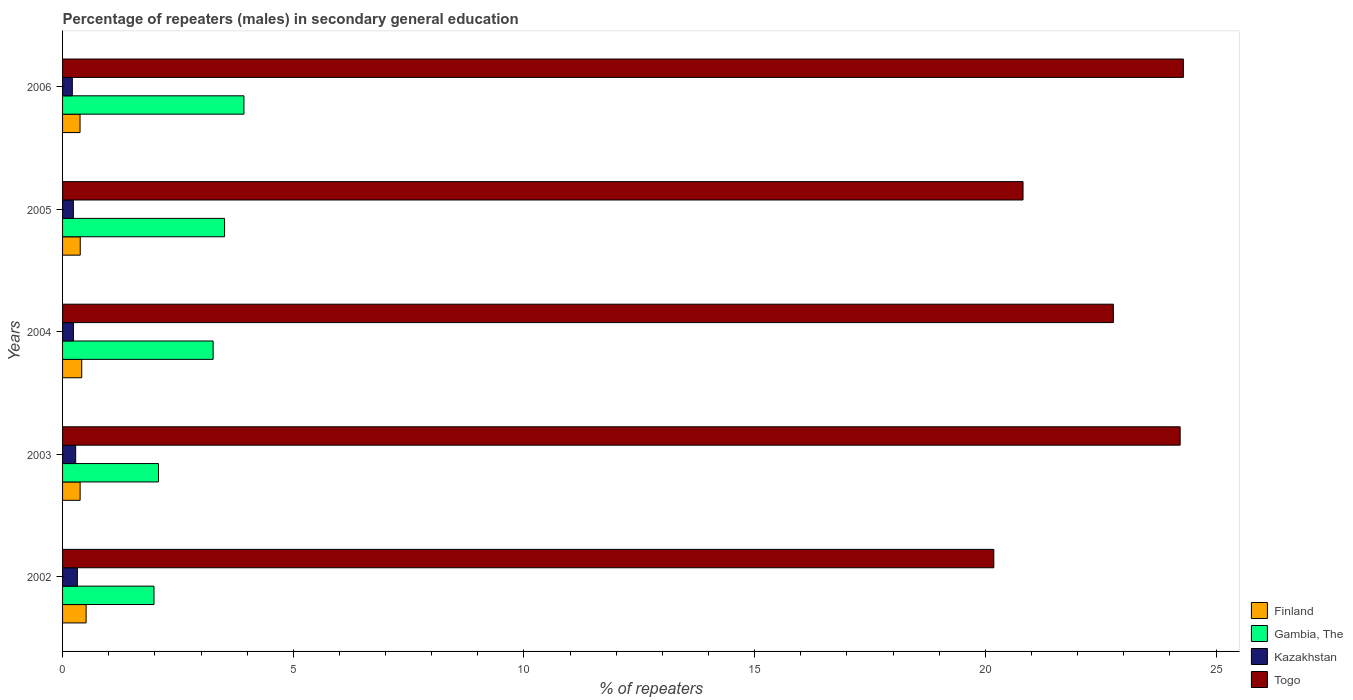How many different coloured bars are there?
Your response must be concise. 4. How many groups of bars are there?
Provide a short and direct response. 5. Are the number of bars on each tick of the Y-axis equal?
Your answer should be compact. Yes. How many bars are there on the 3rd tick from the bottom?
Provide a succinct answer. 4. What is the percentage of male repeaters in Togo in 2006?
Offer a terse response. 24.29. Across all years, what is the maximum percentage of male repeaters in Kazakhstan?
Provide a short and direct response. 0.32. Across all years, what is the minimum percentage of male repeaters in Finland?
Offer a very short reply. 0.38. In which year was the percentage of male repeaters in Togo maximum?
Your answer should be very brief. 2006. In which year was the percentage of male repeaters in Kazakhstan minimum?
Offer a terse response. 2006. What is the total percentage of male repeaters in Finland in the graph?
Make the answer very short. 2.07. What is the difference between the percentage of male repeaters in Finland in 2004 and that in 2006?
Provide a short and direct response. 0.04. What is the difference between the percentage of male repeaters in Gambia, The in 2005 and the percentage of male repeaters in Togo in 2003?
Your answer should be very brief. -20.71. What is the average percentage of male repeaters in Gambia, The per year?
Ensure brevity in your answer.  2.95. In the year 2004, what is the difference between the percentage of male repeaters in Kazakhstan and percentage of male repeaters in Finland?
Ensure brevity in your answer.  -0.18. In how many years, is the percentage of male repeaters in Togo greater than 23 %?
Keep it short and to the point. 2. What is the ratio of the percentage of male repeaters in Gambia, The in 2003 to that in 2005?
Ensure brevity in your answer.  0.59. Is the difference between the percentage of male repeaters in Kazakhstan in 2003 and 2005 greater than the difference between the percentage of male repeaters in Finland in 2003 and 2005?
Your response must be concise. Yes. What is the difference between the highest and the second highest percentage of male repeaters in Gambia, The?
Make the answer very short. 0.42. What is the difference between the highest and the lowest percentage of male repeaters in Gambia, The?
Provide a short and direct response. 1.95. In how many years, is the percentage of male repeaters in Finland greater than the average percentage of male repeaters in Finland taken over all years?
Your answer should be very brief. 2. Is the sum of the percentage of male repeaters in Kazakhstan in 2004 and 2006 greater than the maximum percentage of male repeaters in Togo across all years?
Make the answer very short. No. What does the 2nd bar from the bottom in 2004 represents?
Your answer should be compact. Gambia, The. Is it the case that in every year, the sum of the percentage of male repeaters in Kazakhstan and percentage of male repeaters in Togo is greater than the percentage of male repeaters in Finland?
Make the answer very short. Yes. How many years are there in the graph?
Make the answer very short. 5. Are the values on the major ticks of X-axis written in scientific E-notation?
Keep it short and to the point. No. Does the graph contain any zero values?
Provide a short and direct response. No. Does the graph contain grids?
Give a very brief answer. No. Where does the legend appear in the graph?
Ensure brevity in your answer.  Bottom right. How many legend labels are there?
Provide a succinct answer. 4. How are the legend labels stacked?
Give a very brief answer. Vertical. What is the title of the graph?
Make the answer very short. Percentage of repeaters (males) in secondary general education. Does "Serbia" appear as one of the legend labels in the graph?
Offer a very short reply. No. What is the label or title of the X-axis?
Ensure brevity in your answer.  % of repeaters. What is the label or title of the Y-axis?
Give a very brief answer. Years. What is the % of repeaters in Finland in 2002?
Your answer should be very brief. 0.51. What is the % of repeaters in Gambia, The in 2002?
Provide a succinct answer. 1.98. What is the % of repeaters in Kazakhstan in 2002?
Keep it short and to the point. 0.32. What is the % of repeaters in Togo in 2002?
Keep it short and to the point. 20.18. What is the % of repeaters of Finland in 2003?
Give a very brief answer. 0.38. What is the % of repeaters in Gambia, The in 2003?
Keep it short and to the point. 2.08. What is the % of repeaters of Kazakhstan in 2003?
Offer a terse response. 0.28. What is the % of repeaters in Togo in 2003?
Your answer should be very brief. 24.22. What is the % of repeaters of Finland in 2004?
Provide a succinct answer. 0.42. What is the % of repeaters in Gambia, The in 2004?
Provide a succinct answer. 3.26. What is the % of repeaters in Kazakhstan in 2004?
Your response must be concise. 0.24. What is the % of repeaters in Togo in 2004?
Your answer should be compact. 22.77. What is the % of repeaters of Finland in 2005?
Provide a succinct answer. 0.38. What is the % of repeaters of Gambia, The in 2005?
Offer a very short reply. 3.51. What is the % of repeaters of Kazakhstan in 2005?
Give a very brief answer. 0.23. What is the % of repeaters of Togo in 2005?
Offer a terse response. 20.82. What is the % of repeaters of Finland in 2006?
Provide a succinct answer. 0.38. What is the % of repeaters in Gambia, The in 2006?
Make the answer very short. 3.93. What is the % of repeaters in Kazakhstan in 2006?
Ensure brevity in your answer.  0.21. What is the % of repeaters of Togo in 2006?
Your response must be concise. 24.29. Across all years, what is the maximum % of repeaters in Finland?
Give a very brief answer. 0.51. Across all years, what is the maximum % of repeaters in Gambia, The?
Make the answer very short. 3.93. Across all years, what is the maximum % of repeaters in Kazakhstan?
Provide a short and direct response. 0.32. Across all years, what is the maximum % of repeaters in Togo?
Keep it short and to the point. 24.29. Across all years, what is the minimum % of repeaters in Finland?
Make the answer very short. 0.38. Across all years, what is the minimum % of repeaters in Gambia, The?
Make the answer very short. 1.98. Across all years, what is the minimum % of repeaters in Kazakhstan?
Your response must be concise. 0.21. Across all years, what is the minimum % of repeaters in Togo?
Offer a very short reply. 20.18. What is the total % of repeaters in Finland in the graph?
Ensure brevity in your answer.  2.07. What is the total % of repeaters of Gambia, The in the graph?
Provide a succinct answer. 14.77. What is the total % of repeaters in Kazakhstan in the graph?
Offer a terse response. 1.29. What is the total % of repeaters in Togo in the graph?
Ensure brevity in your answer.  112.28. What is the difference between the % of repeaters in Finland in 2002 and that in 2003?
Your response must be concise. 0.13. What is the difference between the % of repeaters of Gambia, The in 2002 and that in 2003?
Keep it short and to the point. -0.1. What is the difference between the % of repeaters of Kazakhstan in 2002 and that in 2003?
Provide a succinct answer. 0.04. What is the difference between the % of repeaters of Togo in 2002 and that in 2003?
Offer a terse response. -4.04. What is the difference between the % of repeaters of Finland in 2002 and that in 2004?
Offer a terse response. 0.09. What is the difference between the % of repeaters in Gambia, The in 2002 and that in 2004?
Make the answer very short. -1.28. What is the difference between the % of repeaters of Kazakhstan in 2002 and that in 2004?
Offer a terse response. 0.09. What is the difference between the % of repeaters of Togo in 2002 and that in 2004?
Make the answer very short. -2.59. What is the difference between the % of repeaters of Finland in 2002 and that in 2005?
Give a very brief answer. 0.13. What is the difference between the % of repeaters of Gambia, The in 2002 and that in 2005?
Offer a terse response. -1.53. What is the difference between the % of repeaters of Kazakhstan in 2002 and that in 2005?
Offer a terse response. 0.09. What is the difference between the % of repeaters of Togo in 2002 and that in 2005?
Keep it short and to the point. -0.63. What is the difference between the % of repeaters in Finland in 2002 and that in 2006?
Offer a terse response. 0.13. What is the difference between the % of repeaters of Gambia, The in 2002 and that in 2006?
Offer a terse response. -1.95. What is the difference between the % of repeaters in Kazakhstan in 2002 and that in 2006?
Your answer should be very brief. 0.11. What is the difference between the % of repeaters of Togo in 2002 and that in 2006?
Make the answer very short. -4.11. What is the difference between the % of repeaters of Finland in 2003 and that in 2004?
Make the answer very short. -0.04. What is the difference between the % of repeaters in Gambia, The in 2003 and that in 2004?
Provide a succinct answer. -1.18. What is the difference between the % of repeaters of Kazakhstan in 2003 and that in 2004?
Your response must be concise. 0.05. What is the difference between the % of repeaters of Togo in 2003 and that in 2004?
Offer a very short reply. 1.45. What is the difference between the % of repeaters in Finland in 2003 and that in 2005?
Offer a terse response. -0. What is the difference between the % of repeaters of Gambia, The in 2003 and that in 2005?
Your response must be concise. -1.43. What is the difference between the % of repeaters in Kazakhstan in 2003 and that in 2005?
Your answer should be compact. 0.05. What is the difference between the % of repeaters in Togo in 2003 and that in 2005?
Make the answer very short. 3.41. What is the difference between the % of repeaters in Finland in 2003 and that in 2006?
Ensure brevity in your answer.  0. What is the difference between the % of repeaters of Gambia, The in 2003 and that in 2006?
Provide a succinct answer. -1.85. What is the difference between the % of repeaters in Kazakhstan in 2003 and that in 2006?
Provide a succinct answer. 0.07. What is the difference between the % of repeaters in Togo in 2003 and that in 2006?
Offer a terse response. -0.07. What is the difference between the % of repeaters in Finland in 2004 and that in 2005?
Give a very brief answer. 0.03. What is the difference between the % of repeaters in Gambia, The in 2004 and that in 2005?
Provide a short and direct response. -0.25. What is the difference between the % of repeaters of Togo in 2004 and that in 2005?
Ensure brevity in your answer.  1.96. What is the difference between the % of repeaters of Finland in 2004 and that in 2006?
Your answer should be very brief. 0.04. What is the difference between the % of repeaters in Gambia, The in 2004 and that in 2006?
Give a very brief answer. -0.67. What is the difference between the % of repeaters of Kazakhstan in 2004 and that in 2006?
Keep it short and to the point. 0.02. What is the difference between the % of repeaters in Togo in 2004 and that in 2006?
Provide a succinct answer. -1.52. What is the difference between the % of repeaters in Finland in 2005 and that in 2006?
Provide a succinct answer. 0. What is the difference between the % of repeaters in Gambia, The in 2005 and that in 2006?
Offer a terse response. -0.42. What is the difference between the % of repeaters of Kazakhstan in 2005 and that in 2006?
Make the answer very short. 0.02. What is the difference between the % of repeaters in Togo in 2005 and that in 2006?
Make the answer very short. -3.47. What is the difference between the % of repeaters of Finland in 2002 and the % of repeaters of Gambia, The in 2003?
Provide a succinct answer. -1.57. What is the difference between the % of repeaters in Finland in 2002 and the % of repeaters in Kazakhstan in 2003?
Offer a very short reply. 0.23. What is the difference between the % of repeaters of Finland in 2002 and the % of repeaters of Togo in 2003?
Keep it short and to the point. -23.71. What is the difference between the % of repeaters in Gambia, The in 2002 and the % of repeaters in Kazakhstan in 2003?
Offer a terse response. 1.7. What is the difference between the % of repeaters of Gambia, The in 2002 and the % of repeaters of Togo in 2003?
Provide a short and direct response. -22.24. What is the difference between the % of repeaters of Kazakhstan in 2002 and the % of repeaters of Togo in 2003?
Provide a succinct answer. -23.9. What is the difference between the % of repeaters in Finland in 2002 and the % of repeaters in Gambia, The in 2004?
Make the answer very short. -2.75. What is the difference between the % of repeaters in Finland in 2002 and the % of repeaters in Kazakhstan in 2004?
Your answer should be compact. 0.27. What is the difference between the % of repeaters in Finland in 2002 and the % of repeaters in Togo in 2004?
Offer a very short reply. -22.26. What is the difference between the % of repeaters of Gambia, The in 2002 and the % of repeaters of Kazakhstan in 2004?
Provide a short and direct response. 1.75. What is the difference between the % of repeaters in Gambia, The in 2002 and the % of repeaters in Togo in 2004?
Provide a succinct answer. -20.79. What is the difference between the % of repeaters of Kazakhstan in 2002 and the % of repeaters of Togo in 2004?
Your answer should be very brief. -22.45. What is the difference between the % of repeaters in Finland in 2002 and the % of repeaters in Gambia, The in 2005?
Make the answer very short. -3. What is the difference between the % of repeaters of Finland in 2002 and the % of repeaters of Kazakhstan in 2005?
Your response must be concise. 0.28. What is the difference between the % of repeaters of Finland in 2002 and the % of repeaters of Togo in 2005?
Make the answer very short. -20.31. What is the difference between the % of repeaters in Gambia, The in 2002 and the % of repeaters in Kazakhstan in 2005?
Make the answer very short. 1.75. What is the difference between the % of repeaters of Gambia, The in 2002 and the % of repeaters of Togo in 2005?
Your answer should be compact. -18.83. What is the difference between the % of repeaters of Kazakhstan in 2002 and the % of repeaters of Togo in 2005?
Offer a terse response. -20.49. What is the difference between the % of repeaters in Finland in 2002 and the % of repeaters in Gambia, The in 2006?
Give a very brief answer. -3.42. What is the difference between the % of repeaters in Finland in 2002 and the % of repeaters in Kazakhstan in 2006?
Ensure brevity in your answer.  0.3. What is the difference between the % of repeaters of Finland in 2002 and the % of repeaters of Togo in 2006?
Your response must be concise. -23.78. What is the difference between the % of repeaters of Gambia, The in 2002 and the % of repeaters of Kazakhstan in 2006?
Offer a terse response. 1.77. What is the difference between the % of repeaters in Gambia, The in 2002 and the % of repeaters in Togo in 2006?
Your response must be concise. -22.31. What is the difference between the % of repeaters in Kazakhstan in 2002 and the % of repeaters in Togo in 2006?
Give a very brief answer. -23.97. What is the difference between the % of repeaters of Finland in 2003 and the % of repeaters of Gambia, The in 2004?
Offer a terse response. -2.88. What is the difference between the % of repeaters of Finland in 2003 and the % of repeaters of Kazakhstan in 2004?
Offer a terse response. 0.15. What is the difference between the % of repeaters of Finland in 2003 and the % of repeaters of Togo in 2004?
Offer a very short reply. -22.39. What is the difference between the % of repeaters of Gambia, The in 2003 and the % of repeaters of Kazakhstan in 2004?
Your answer should be very brief. 1.84. What is the difference between the % of repeaters in Gambia, The in 2003 and the % of repeaters in Togo in 2004?
Keep it short and to the point. -20.69. What is the difference between the % of repeaters in Kazakhstan in 2003 and the % of repeaters in Togo in 2004?
Your answer should be very brief. -22.49. What is the difference between the % of repeaters in Finland in 2003 and the % of repeaters in Gambia, The in 2005?
Your response must be concise. -3.13. What is the difference between the % of repeaters of Finland in 2003 and the % of repeaters of Kazakhstan in 2005?
Your answer should be compact. 0.15. What is the difference between the % of repeaters in Finland in 2003 and the % of repeaters in Togo in 2005?
Offer a terse response. -20.43. What is the difference between the % of repeaters of Gambia, The in 2003 and the % of repeaters of Kazakhstan in 2005?
Your response must be concise. 1.84. What is the difference between the % of repeaters of Gambia, The in 2003 and the % of repeaters of Togo in 2005?
Offer a very short reply. -18.74. What is the difference between the % of repeaters of Kazakhstan in 2003 and the % of repeaters of Togo in 2005?
Offer a terse response. -20.53. What is the difference between the % of repeaters in Finland in 2003 and the % of repeaters in Gambia, The in 2006?
Provide a succinct answer. -3.55. What is the difference between the % of repeaters in Finland in 2003 and the % of repeaters in Kazakhstan in 2006?
Provide a succinct answer. 0.17. What is the difference between the % of repeaters in Finland in 2003 and the % of repeaters in Togo in 2006?
Your answer should be compact. -23.91. What is the difference between the % of repeaters in Gambia, The in 2003 and the % of repeaters in Kazakhstan in 2006?
Make the answer very short. 1.87. What is the difference between the % of repeaters of Gambia, The in 2003 and the % of repeaters of Togo in 2006?
Your answer should be very brief. -22.21. What is the difference between the % of repeaters in Kazakhstan in 2003 and the % of repeaters in Togo in 2006?
Your answer should be very brief. -24.01. What is the difference between the % of repeaters in Finland in 2004 and the % of repeaters in Gambia, The in 2005?
Keep it short and to the point. -3.1. What is the difference between the % of repeaters in Finland in 2004 and the % of repeaters in Kazakhstan in 2005?
Your answer should be compact. 0.18. What is the difference between the % of repeaters in Finland in 2004 and the % of repeaters in Togo in 2005?
Ensure brevity in your answer.  -20.4. What is the difference between the % of repeaters in Gambia, The in 2004 and the % of repeaters in Kazakhstan in 2005?
Make the answer very short. 3.03. What is the difference between the % of repeaters of Gambia, The in 2004 and the % of repeaters of Togo in 2005?
Make the answer very short. -17.55. What is the difference between the % of repeaters in Kazakhstan in 2004 and the % of repeaters in Togo in 2005?
Give a very brief answer. -20.58. What is the difference between the % of repeaters of Finland in 2004 and the % of repeaters of Gambia, The in 2006?
Offer a terse response. -3.52. What is the difference between the % of repeaters of Finland in 2004 and the % of repeaters of Kazakhstan in 2006?
Provide a succinct answer. 0.2. What is the difference between the % of repeaters of Finland in 2004 and the % of repeaters of Togo in 2006?
Give a very brief answer. -23.87. What is the difference between the % of repeaters in Gambia, The in 2004 and the % of repeaters in Kazakhstan in 2006?
Offer a very short reply. 3.05. What is the difference between the % of repeaters of Gambia, The in 2004 and the % of repeaters of Togo in 2006?
Give a very brief answer. -21.03. What is the difference between the % of repeaters of Kazakhstan in 2004 and the % of repeaters of Togo in 2006?
Give a very brief answer. -24.05. What is the difference between the % of repeaters of Finland in 2005 and the % of repeaters of Gambia, The in 2006?
Offer a very short reply. -3.55. What is the difference between the % of repeaters in Finland in 2005 and the % of repeaters in Kazakhstan in 2006?
Give a very brief answer. 0.17. What is the difference between the % of repeaters of Finland in 2005 and the % of repeaters of Togo in 2006?
Provide a succinct answer. -23.91. What is the difference between the % of repeaters of Gambia, The in 2005 and the % of repeaters of Kazakhstan in 2006?
Keep it short and to the point. 3.3. What is the difference between the % of repeaters in Gambia, The in 2005 and the % of repeaters in Togo in 2006?
Your answer should be compact. -20.78. What is the difference between the % of repeaters of Kazakhstan in 2005 and the % of repeaters of Togo in 2006?
Make the answer very short. -24.06. What is the average % of repeaters of Finland per year?
Provide a short and direct response. 0.41. What is the average % of repeaters of Gambia, The per year?
Keep it short and to the point. 2.95. What is the average % of repeaters in Kazakhstan per year?
Ensure brevity in your answer.  0.26. What is the average % of repeaters of Togo per year?
Keep it short and to the point. 22.46. In the year 2002, what is the difference between the % of repeaters in Finland and % of repeaters in Gambia, The?
Your answer should be compact. -1.47. In the year 2002, what is the difference between the % of repeaters of Finland and % of repeaters of Kazakhstan?
Your answer should be very brief. 0.19. In the year 2002, what is the difference between the % of repeaters in Finland and % of repeaters in Togo?
Provide a short and direct response. -19.67. In the year 2002, what is the difference between the % of repeaters of Gambia, The and % of repeaters of Kazakhstan?
Your answer should be compact. 1.66. In the year 2002, what is the difference between the % of repeaters in Gambia, The and % of repeaters in Togo?
Provide a succinct answer. -18.2. In the year 2002, what is the difference between the % of repeaters of Kazakhstan and % of repeaters of Togo?
Provide a short and direct response. -19.86. In the year 2003, what is the difference between the % of repeaters in Finland and % of repeaters in Gambia, The?
Offer a very short reply. -1.7. In the year 2003, what is the difference between the % of repeaters in Finland and % of repeaters in Kazakhstan?
Provide a succinct answer. 0.1. In the year 2003, what is the difference between the % of repeaters of Finland and % of repeaters of Togo?
Your answer should be very brief. -23.84. In the year 2003, what is the difference between the % of repeaters of Gambia, The and % of repeaters of Kazakhstan?
Keep it short and to the point. 1.79. In the year 2003, what is the difference between the % of repeaters in Gambia, The and % of repeaters in Togo?
Provide a succinct answer. -22.14. In the year 2003, what is the difference between the % of repeaters in Kazakhstan and % of repeaters in Togo?
Give a very brief answer. -23.94. In the year 2004, what is the difference between the % of repeaters of Finland and % of repeaters of Gambia, The?
Your answer should be compact. -2.85. In the year 2004, what is the difference between the % of repeaters of Finland and % of repeaters of Kazakhstan?
Provide a short and direct response. 0.18. In the year 2004, what is the difference between the % of repeaters of Finland and % of repeaters of Togo?
Offer a terse response. -22.36. In the year 2004, what is the difference between the % of repeaters of Gambia, The and % of repeaters of Kazakhstan?
Offer a terse response. 3.03. In the year 2004, what is the difference between the % of repeaters of Gambia, The and % of repeaters of Togo?
Offer a terse response. -19.51. In the year 2004, what is the difference between the % of repeaters in Kazakhstan and % of repeaters in Togo?
Your response must be concise. -22.54. In the year 2005, what is the difference between the % of repeaters of Finland and % of repeaters of Gambia, The?
Provide a succinct answer. -3.13. In the year 2005, what is the difference between the % of repeaters of Finland and % of repeaters of Kazakhstan?
Provide a succinct answer. 0.15. In the year 2005, what is the difference between the % of repeaters of Finland and % of repeaters of Togo?
Your response must be concise. -20.43. In the year 2005, what is the difference between the % of repeaters of Gambia, The and % of repeaters of Kazakhstan?
Provide a succinct answer. 3.28. In the year 2005, what is the difference between the % of repeaters in Gambia, The and % of repeaters in Togo?
Your answer should be very brief. -17.3. In the year 2005, what is the difference between the % of repeaters in Kazakhstan and % of repeaters in Togo?
Provide a succinct answer. -20.58. In the year 2006, what is the difference between the % of repeaters in Finland and % of repeaters in Gambia, The?
Ensure brevity in your answer.  -3.55. In the year 2006, what is the difference between the % of repeaters of Finland and % of repeaters of Kazakhstan?
Make the answer very short. 0.17. In the year 2006, what is the difference between the % of repeaters of Finland and % of repeaters of Togo?
Give a very brief answer. -23.91. In the year 2006, what is the difference between the % of repeaters in Gambia, The and % of repeaters in Kazakhstan?
Provide a short and direct response. 3.72. In the year 2006, what is the difference between the % of repeaters of Gambia, The and % of repeaters of Togo?
Keep it short and to the point. -20.36. In the year 2006, what is the difference between the % of repeaters of Kazakhstan and % of repeaters of Togo?
Your answer should be compact. -24.08. What is the ratio of the % of repeaters in Finland in 2002 to that in 2003?
Offer a terse response. 1.34. What is the ratio of the % of repeaters of Gambia, The in 2002 to that in 2003?
Your answer should be compact. 0.95. What is the ratio of the % of repeaters of Kazakhstan in 2002 to that in 2003?
Your response must be concise. 1.13. What is the ratio of the % of repeaters in Finland in 2002 to that in 2004?
Provide a succinct answer. 1.23. What is the ratio of the % of repeaters of Gambia, The in 2002 to that in 2004?
Give a very brief answer. 0.61. What is the ratio of the % of repeaters in Kazakhstan in 2002 to that in 2004?
Your answer should be very brief. 1.36. What is the ratio of the % of repeaters in Togo in 2002 to that in 2004?
Offer a terse response. 0.89. What is the ratio of the % of repeaters in Finland in 2002 to that in 2005?
Your response must be concise. 1.33. What is the ratio of the % of repeaters of Gambia, The in 2002 to that in 2005?
Ensure brevity in your answer.  0.56. What is the ratio of the % of repeaters of Kazakhstan in 2002 to that in 2005?
Your answer should be very brief. 1.37. What is the ratio of the % of repeaters in Togo in 2002 to that in 2005?
Ensure brevity in your answer.  0.97. What is the ratio of the % of repeaters in Finland in 2002 to that in 2006?
Your answer should be compact. 1.35. What is the ratio of the % of repeaters of Gambia, The in 2002 to that in 2006?
Your answer should be compact. 0.5. What is the ratio of the % of repeaters in Kazakhstan in 2002 to that in 2006?
Ensure brevity in your answer.  1.52. What is the ratio of the % of repeaters in Togo in 2002 to that in 2006?
Your answer should be very brief. 0.83. What is the ratio of the % of repeaters of Finland in 2003 to that in 2004?
Offer a terse response. 0.92. What is the ratio of the % of repeaters of Gambia, The in 2003 to that in 2004?
Offer a terse response. 0.64. What is the ratio of the % of repeaters in Kazakhstan in 2003 to that in 2004?
Offer a terse response. 1.21. What is the ratio of the % of repeaters of Togo in 2003 to that in 2004?
Keep it short and to the point. 1.06. What is the ratio of the % of repeaters in Gambia, The in 2003 to that in 2005?
Your response must be concise. 0.59. What is the ratio of the % of repeaters of Kazakhstan in 2003 to that in 2005?
Offer a very short reply. 1.21. What is the ratio of the % of repeaters in Togo in 2003 to that in 2005?
Your answer should be very brief. 1.16. What is the ratio of the % of repeaters in Finland in 2003 to that in 2006?
Keep it short and to the point. 1. What is the ratio of the % of repeaters of Gambia, The in 2003 to that in 2006?
Offer a very short reply. 0.53. What is the ratio of the % of repeaters of Kazakhstan in 2003 to that in 2006?
Ensure brevity in your answer.  1.34. What is the ratio of the % of repeaters in Togo in 2003 to that in 2006?
Offer a terse response. 1. What is the ratio of the % of repeaters of Finland in 2004 to that in 2005?
Your answer should be very brief. 1.08. What is the ratio of the % of repeaters of Gambia, The in 2004 to that in 2005?
Ensure brevity in your answer.  0.93. What is the ratio of the % of repeaters in Togo in 2004 to that in 2005?
Provide a short and direct response. 1.09. What is the ratio of the % of repeaters in Finland in 2004 to that in 2006?
Your answer should be compact. 1.1. What is the ratio of the % of repeaters in Gambia, The in 2004 to that in 2006?
Your answer should be compact. 0.83. What is the ratio of the % of repeaters in Kazakhstan in 2004 to that in 2006?
Offer a very short reply. 1.11. What is the ratio of the % of repeaters of Finland in 2005 to that in 2006?
Ensure brevity in your answer.  1.01. What is the ratio of the % of repeaters of Gambia, The in 2005 to that in 2006?
Keep it short and to the point. 0.89. What is the ratio of the % of repeaters in Kazakhstan in 2005 to that in 2006?
Your answer should be compact. 1.11. What is the ratio of the % of repeaters in Togo in 2005 to that in 2006?
Your answer should be very brief. 0.86. What is the difference between the highest and the second highest % of repeaters in Finland?
Provide a short and direct response. 0.09. What is the difference between the highest and the second highest % of repeaters in Gambia, The?
Give a very brief answer. 0.42. What is the difference between the highest and the second highest % of repeaters of Kazakhstan?
Make the answer very short. 0.04. What is the difference between the highest and the second highest % of repeaters in Togo?
Your answer should be compact. 0.07. What is the difference between the highest and the lowest % of repeaters of Finland?
Keep it short and to the point. 0.13. What is the difference between the highest and the lowest % of repeaters in Gambia, The?
Keep it short and to the point. 1.95. What is the difference between the highest and the lowest % of repeaters of Kazakhstan?
Make the answer very short. 0.11. What is the difference between the highest and the lowest % of repeaters in Togo?
Provide a succinct answer. 4.11. 